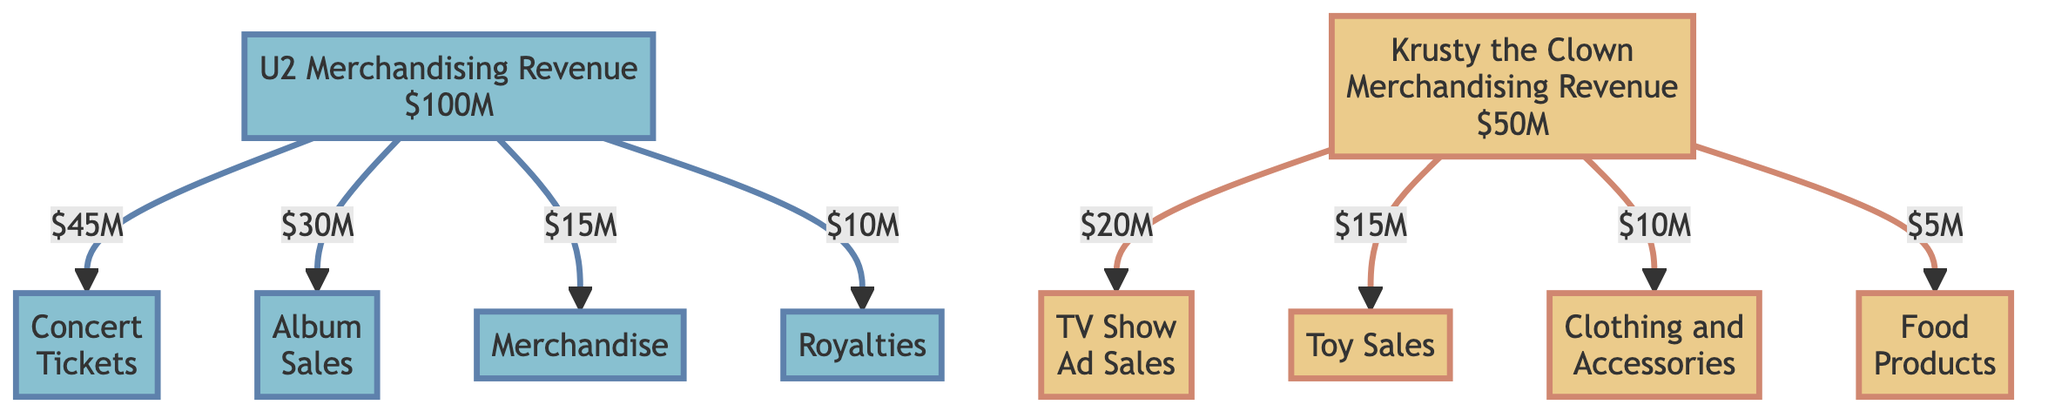What is the total merchandising revenue for U2? The diagram shows that the total revenue for U2 is listed directly under the U2 node, which states "$100M".
Answer: 100 million USD What revenue does U2 earn from concert tickets? Following the arrow from the U2 node to the Concert Tickets node, it shows that the revenue is "$45M".
Answer: 45 million USD How much revenue does Krusty the Clown generate from toy sales? The arrow connecting the Krusty the Clown node to the Toy Sales node indicates the revenue from toy sales is "$15M".
Answer: 15 million USD Which source generates the highest revenue for U2? By examining the revenue breakdown for U2, Concert Tickets at "$45M" is the largest amount listed compared to other categories, which are lower.
Answer: Concert Tickets What is the total revenue from Krusty the Clown's food products? The Food Products node, when traced from the main Krusty the Clown node, clearly states the revenue is "$5M".
Answer: 5 million USD What is the combined revenue from merchandise and royalties for U2? First, we take the revenue from Merchandise ("$15M") and Royalties ("$10M") and add them together, resulting in "$25M" total.
Answer: 25 million USD Which merchandising category has the least revenue for Krusty the Clown? Looking at the breakdown for Krusty the Clown, the Food Products category, at "$5M", is the lowest compared to other categories.
Answer: Food Products What percentage of U2's total revenue comes from album sales? To find the percentage, divide the album sales revenue ("$30M") by the total revenue ("$100M") and multiply by 100, resulting in 30%.
Answer: 30% How many categories contribute to U2's merchandising revenue? The revenue breakdown for U2 lists four distinct sources of revenue: Concert Tickets, Album Sales, Merchandise, and Royalties.
Answer: Four categories What is the total merchandising revenue for both U2 and Krusty the Clown combined? The total merchandising revenue for U2 is "$100M" and for Krusty the Clown it is "$50M". Adding these two figures gives a total of "$150M".
Answer: 150 million USD 